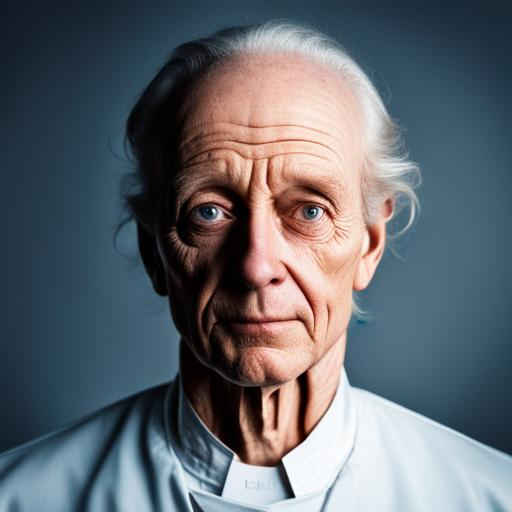What could be the age range of the person in this image? The person in the image appears to be an older adult, likely in their late 60s to late 70s, as indicated by the visible lines and signs of aging on their face. 